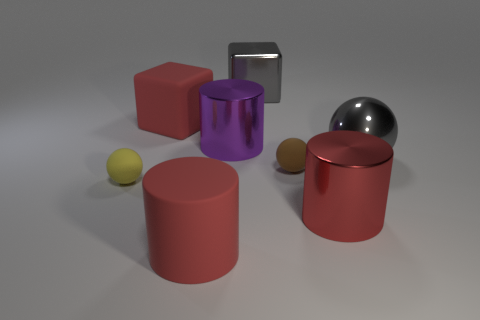What number of big things are either gray shiny cubes or red matte blocks?
Provide a short and direct response. 2. Are there more large gray metallic spheres to the right of the large metallic block than purple shiny objects on the right side of the red metal object?
Give a very brief answer. Yes. There is a object that is the same color as the large metallic block; what is its size?
Offer a very short reply. Large. What number of other objects are there of the same size as the red rubber cube?
Provide a succinct answer. 5. Does the large cylinder that is behind the yellow matte object have the same material as the small yellow ball?
Provide a short and direct response. No. What number of other things are there of the same color as the shiny ball?
Keep it short and to the point. 1. What number of other things are the same shape as the small yellow rubber thing?
Your answer should be very brief. 2. Does the big gray object to the left of the large gray ball have the same shape as the big red thing behind the red metal object?
Your response must be concise. Yes. Is the number of purple things in front of the tiny brown thing the same as the number of shiny objects behind the large purple thing?
Your response must be concise. No. There is a gray metal thing that is on the right side of the tiny object that is to the right of the big metal cylinder behind the red metallic object; what shape is it?
Provide a succinct answer. Sphere. 